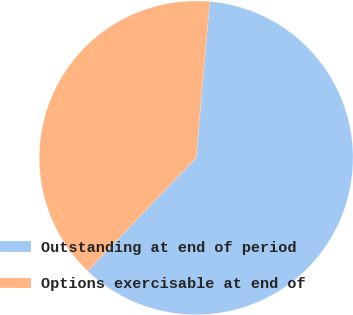Convert chart. <chart><loc_0><loc_0><loc_500><loc_500><pie_chart><fcel>Outstanding at end of period<fcel>Options exercisable at end of<nl><fcel>60.79%<fcel>39.21%<nl></chart> 